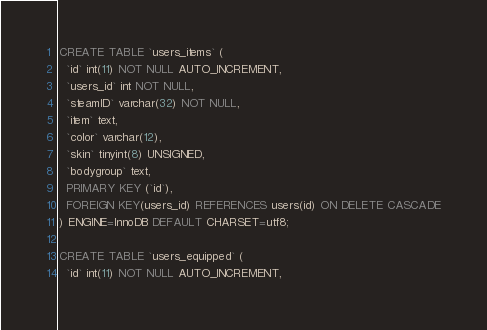<code> <loc_0><loc_0><loc_500><loc_500><_SQL_>CREATE TABLE `users_items` (
  `id` int(11) NOT NULL AUTO_INCREMENT,
  `users_id` int NOT NULL,
  `steamID` varchar(32) NOT NULL,
  `item` text,
  `color` varchar(12),
  `skin` tinyint(8) UNSIGNED,
  `bodygroup` text,
  PRIMARY KEY (`id`),
  FOREIGN KEY(users_id) REFERENCES users(id) ON DELETE CASCADE
) ENGINE=InnoDB DEFAULT CHARSET=utf8;

CREATE TABLE `users_equipped` (
  `id` int(11) NOT NULL AUTO_INCREMENT,</code> 